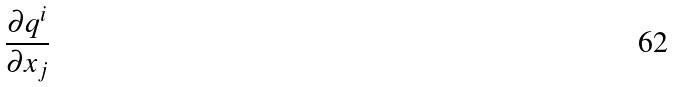<formula> <loc_0><loc_0><loc_500><loc_500>\frac { \partial q ^ { i } } { \partial x _ { j } }</formula> 